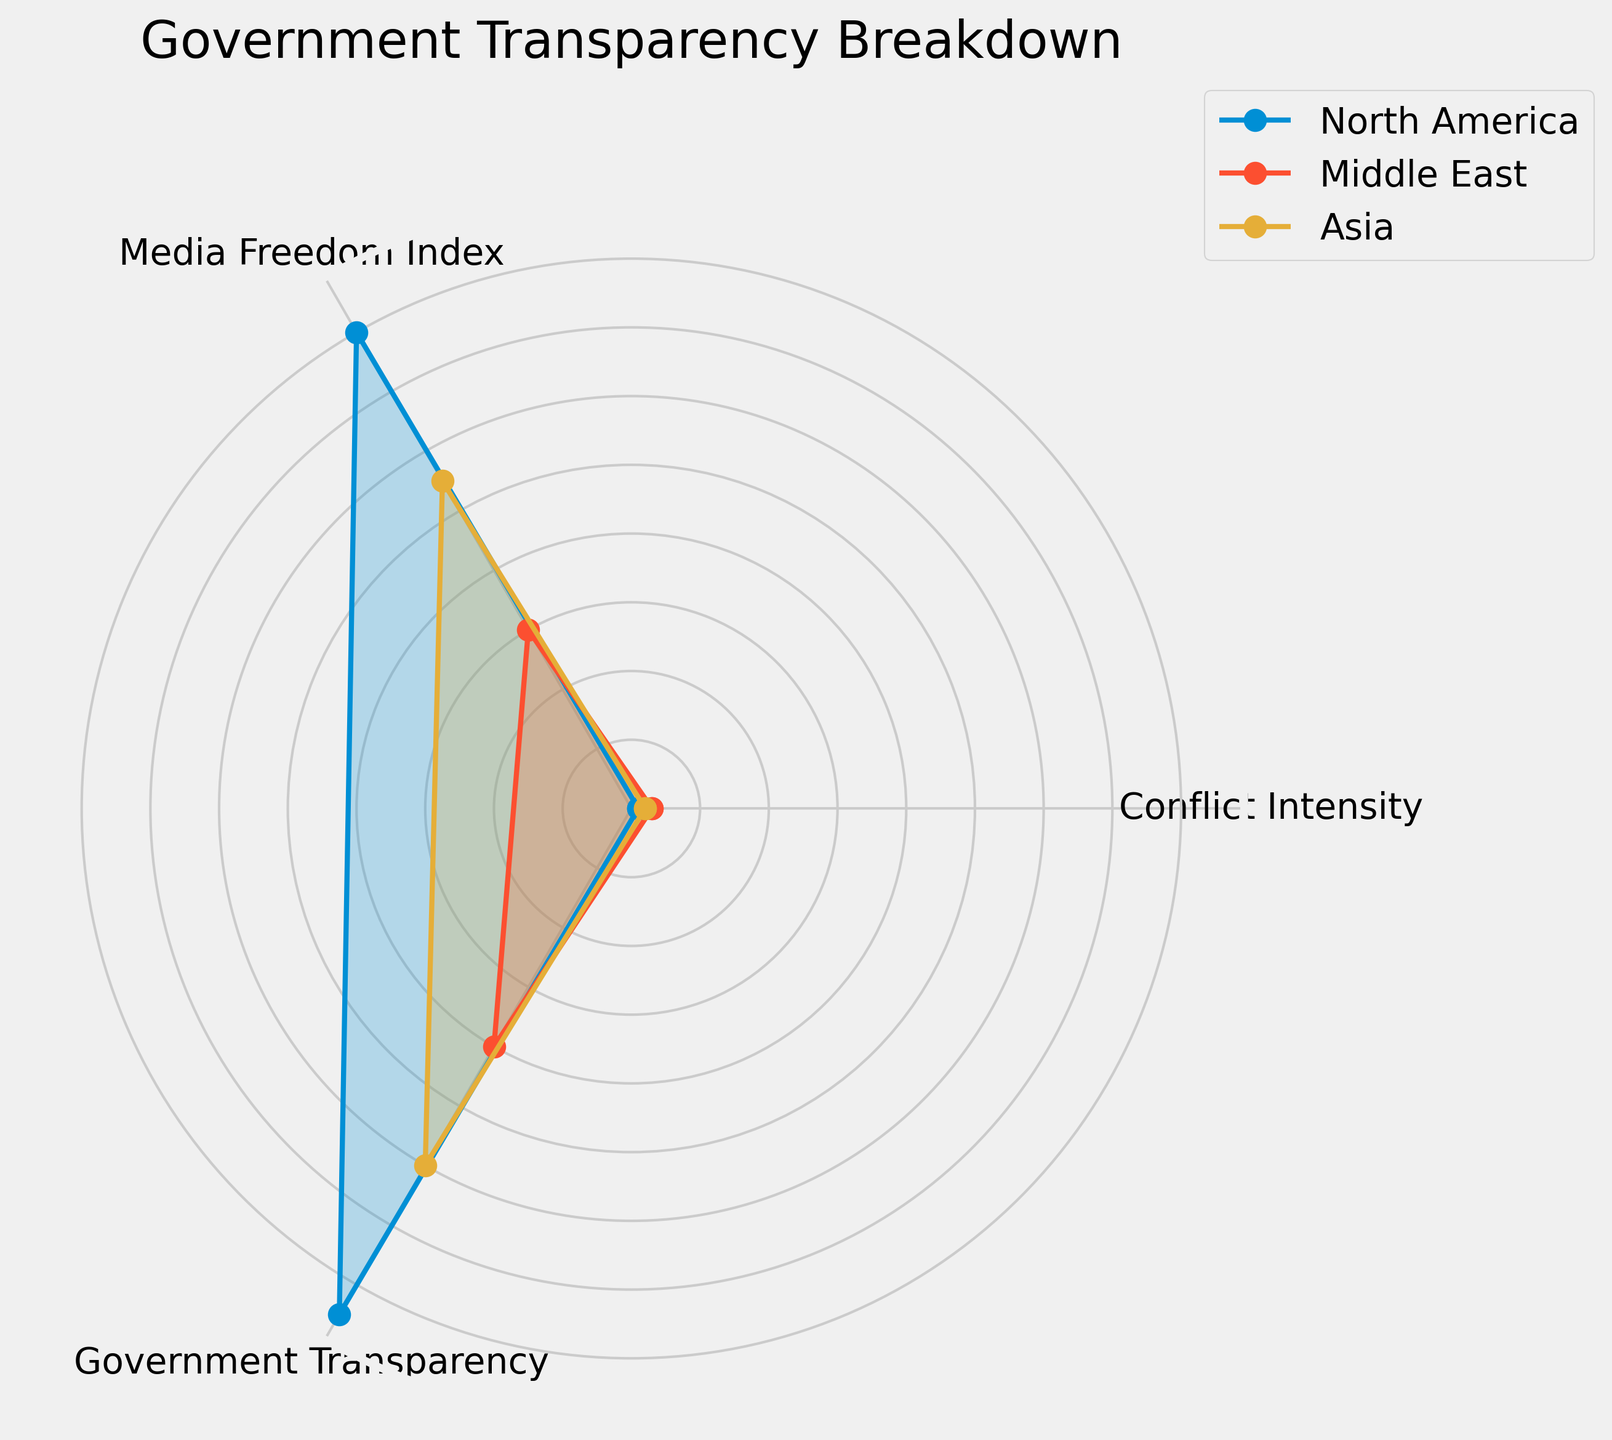What regions are compared in the radar chart? By observing the radar chart, we can identify the labels indicating 'North America', 'Middle East', and 'Asia' as the regions under comparison.
Answer: North America, Middle East, Asia Which region has the highest Media Freedom Index? The chart shows three regions, and each has a designated value for Media Freedom Index. By looking at the angles associated with Media Freedom Index, we can see that North America stands out with the highest value.
Answer: North America How does the Government Transparency in the Middle East compare to that in North America? To answer this, locate the values at the angle for Government Transparency for both regions. North America's value is 85, and Middle East's value is 40. Therefore, North America's Government Transparency is considerably higher.
Answer: North America's is higher What is the average Government Transparency rating across the three regions? From the radar chart, extract the Government Transparency ratings: North America (85), Middle East (40), and Asia (60). Adding these up, (85 + 40 + 60), we get 185. Dividing by 3 regions gives an average of 61.67.
Answer: 61.67 Among the three regions, which one has the highest Conflict Intensity? According to the radar chart, Conflict Intensity is numerically represented. The highest value, corresponding to 'High', is shown for the Middle East.
Answer: Middle East Compare the Media Freedom Index between North America and Asia. The radar chart shows North America with a Media Freedom Index of 80 and Asia with a Media Freedom Index of 55. North America has a higher Media Freedom Index in comparison.
Answer: North America has a higher Media Freedom Index Which region has the lowest Government Transparency rating? By identifying the minimum value on the radar chart for Government Transparency, we observe that the Middle East has the lowest rating among the compared regions.
Answer: Middle East What is the sum of Conflict Intensity values for all three regions? Extracting the Conflict Intensity values from the radar chart: North America (1 for Low), Middle East (3 for High), and Asia (2 for Medium). Summing these values (1 + 3 + 2) results in a total of 6.
Answer: 6 Analyze the relationship between Conflict Intensity and Government Transparency for the Middle East. For the Middle East, the radar chart shows a high Conflict Intensity (value of 3) and a Government Transparency of 40. Higher Conflict Intensity is associated with lower Government Transparency.
Answer: High Conflict Intensity correlates with lower Government Transparency 